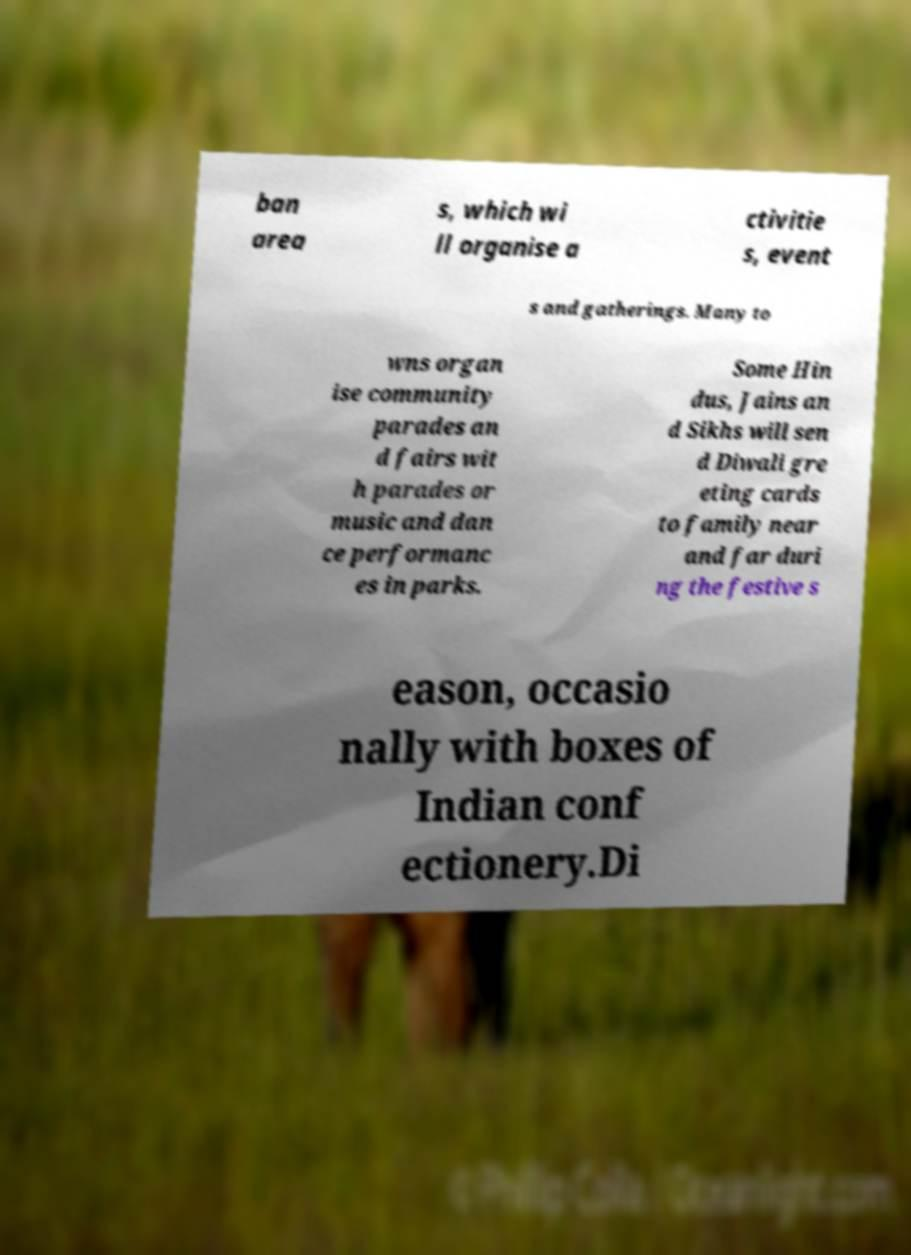For documentation purposes, I need the text within this image transcribed. Could you provide that? ban area s, which wi ll organise a ctivitie s, event s and gatherings. Many to wns organ ise community parades an d fairs wit h parades or music and dan ce performanc es in parks. Some Hin dus, Jains an d Sikhs will sen d Diwali gre eting cards to family near and far duri ng the festive s eason, occasio nally with boxes of Indian conf ectionery.Di 